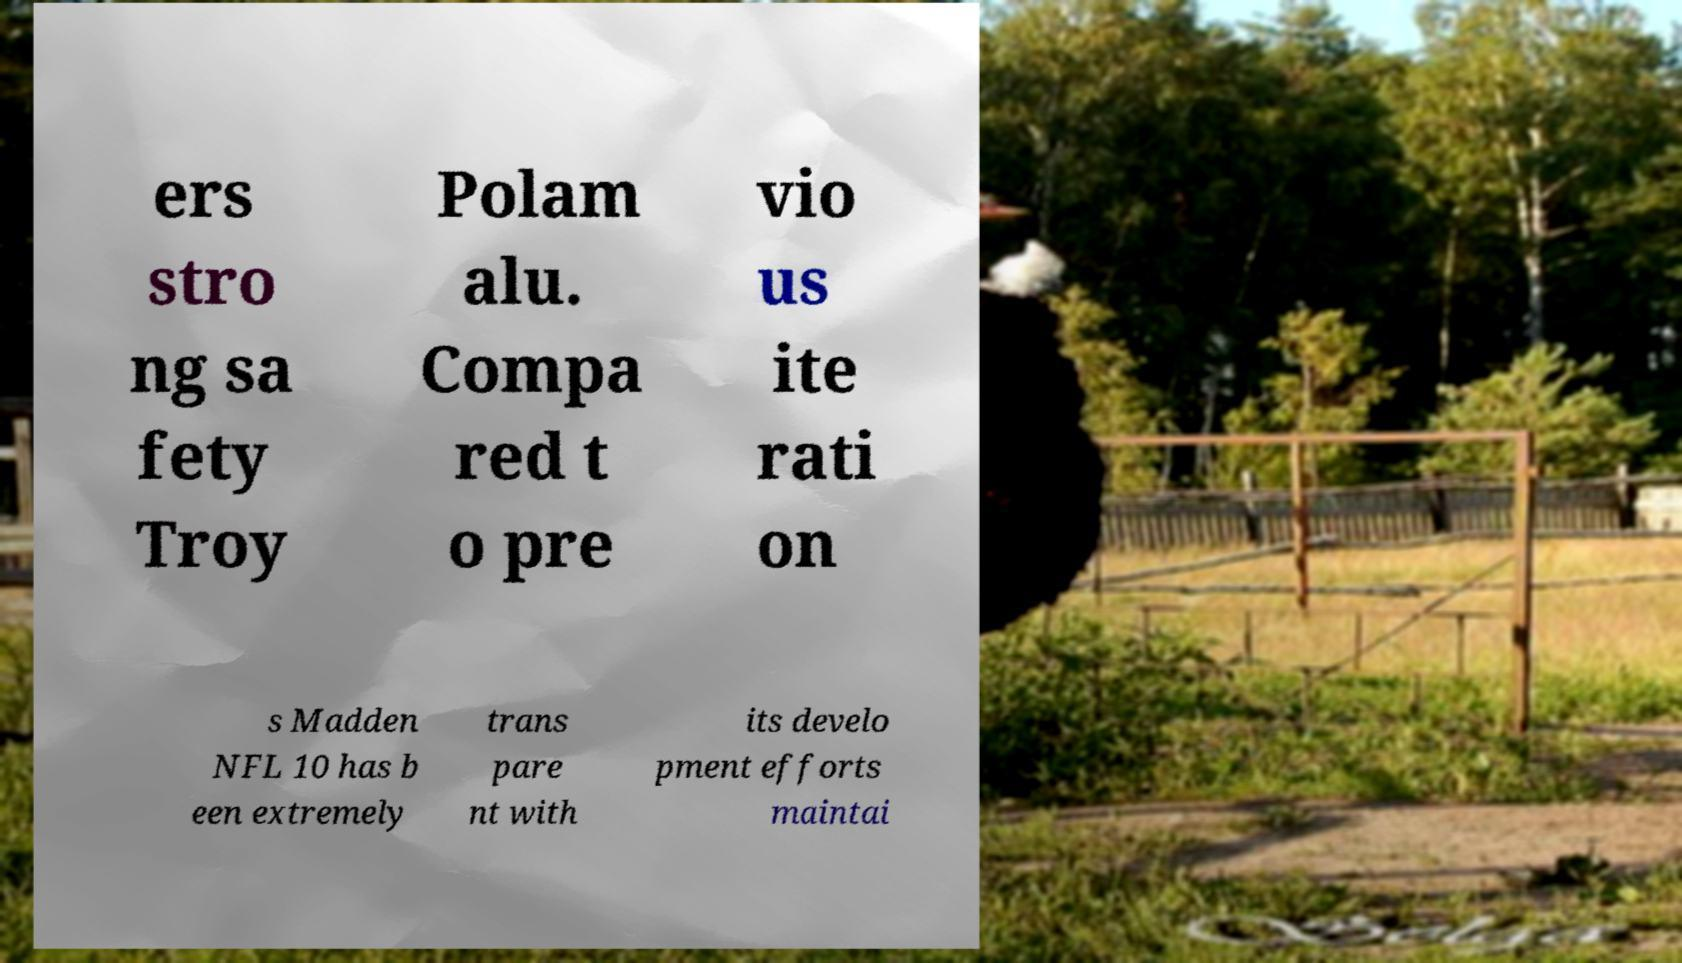Can you read and provide the text displayed in the image?This photo seems to have some interesting text. Can you extract and type it out for me? ers stro ng sa fety Troy Polam alu. Compa red t o pre vio us ite rati on s Madden NFL 10 has b een extremely trans pare nt with its develo pment efforts maintai 